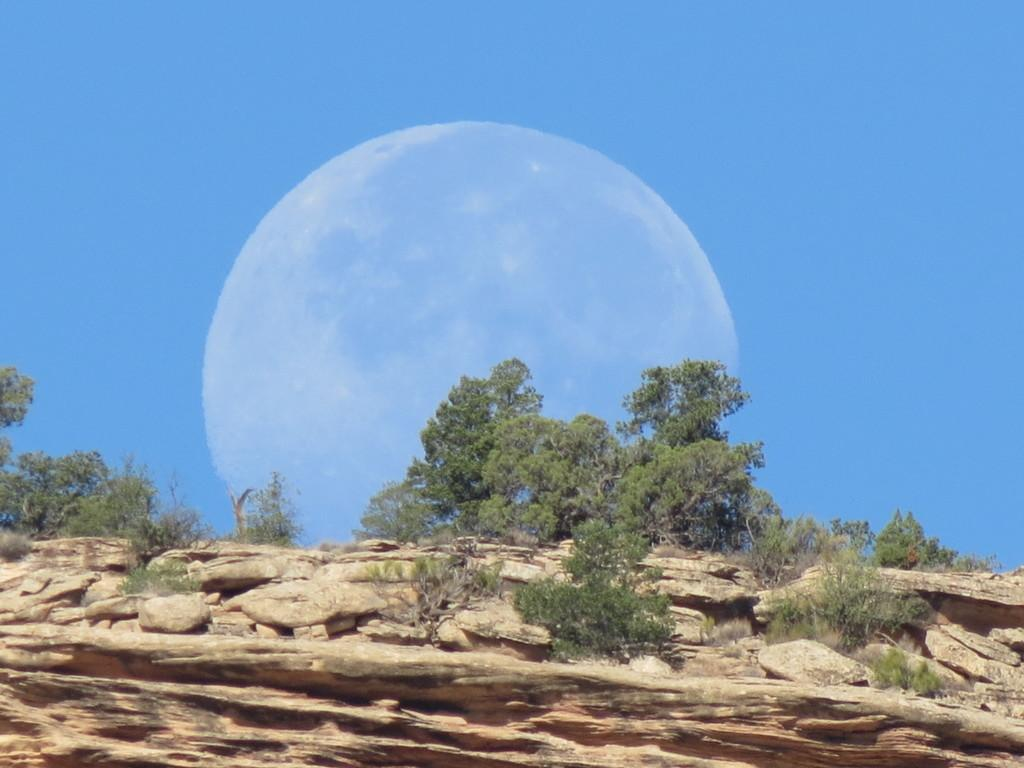What can be seen at the top of the image? The sky is visible towards the top of the image. What is present in the sky? The moon is present in the sky. What type of vegetation can be seen in the image? There are trees and plants in the image. What type of natural formation is present towards the bottom of the image? Rocks are present towards the bottom of the image. How does the moon use water to reflect light in the image? The moon does not use water to reflect light in the image; it reflects sunlight naturally. What type of recess can be seen in the image? There is no recess present in the image. 